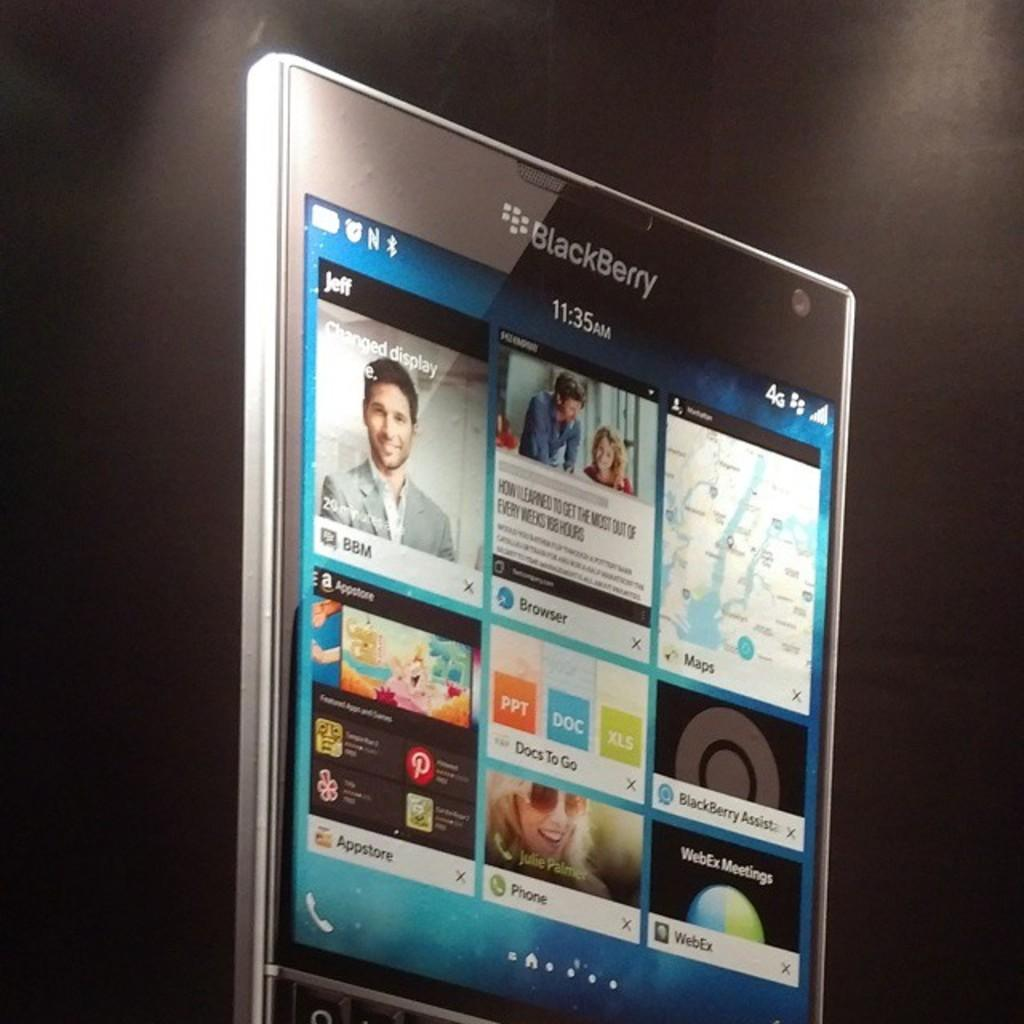<image>
Describe the image concisely. A Blackberry displaying some of its apps on the home screen. 